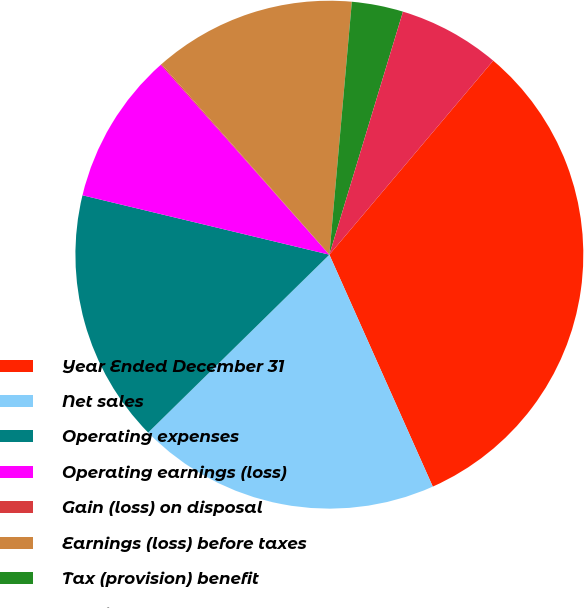Convert chart to OTSL. <chart><loc_0><loc_0><loc_500><loc_500><pie_chart><fcel>Year Ended December 31<fcel>Net sales<fcel>Operating expenses<fcel>Operating earnings (loss)<fcel>Gain (loss) on disposal<fcel>Earnings (loss) before taxes<fcel>Tax (provision) benefit<fcel>Earnings (loss) from<nl><fcel>32.16%<fcel>19.32%<fcel>16.11%<fcel>9.69%<fcel>0.06%<fcel>12.9%<fcel>3.27%<fcel>6.48%<nl></chart> 